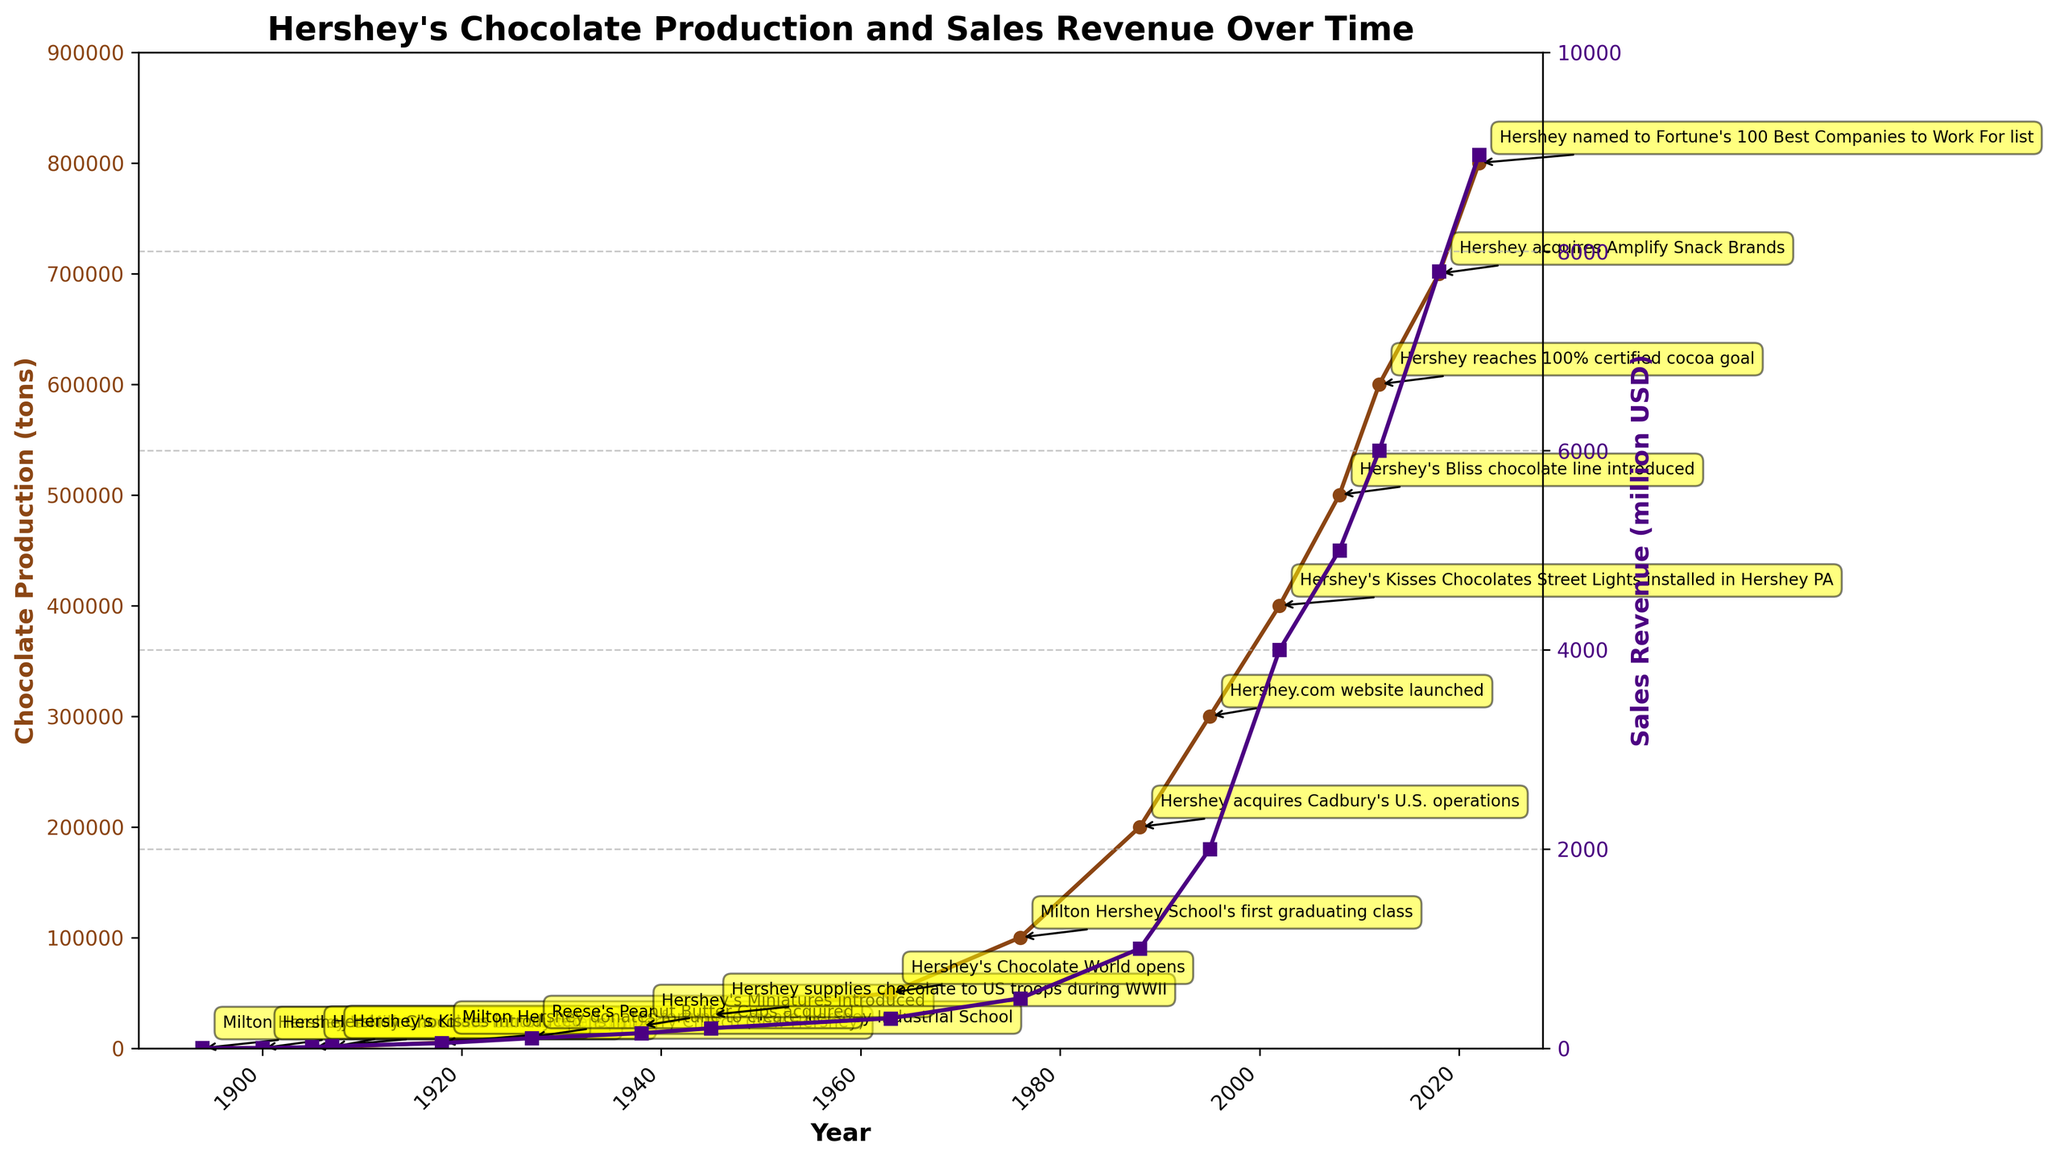What was the chocolate production in tons when Hershey acquired Reese's Peanut Butter Cups? Locate the key milestone "Reese's Peanut Butter Cups acquired" in 1927, and check the corresponding chocolate production value.
Answer: 10,000 tons When did Hershey first reach 300,000 tons of chocolate production? Look for the first occurrence of the chocolate production value reaching 300,000 tons on the x-axis. It reaches this level in 1995.
Answer: 1995 How much higher was the chocolate production in 2018 compared to 2008? Subtract the chocolate production value in 2008 from that in 2018: 700,000 - 500,000.
Answer: 200,000 tons Which year had the highest sales revenue and what was the amount? Identify the highest point on the sales revenue y-axis and note the corresponding year and value. In 2022, sales revenue was the highest at 8,971 million USD.
Answer: 2022; 8,971 million USD Identify the first year Hershey's chocolate production exceeded 100,000 tons. Look along the timeline for the first instance when chocolate production surpasses 100,000 tons. This happens in 1976.
Answer: 1976 Compare the chocolate production in the year Hershey’s Milk Chocolate Bar was introduced to the production in the year Hershey.com was launched. Check the chocolate production values for 1900 and 1995, then note the comparison: 50 tons (1900) vs. 300,000 tons (1995).
Answer: 50 tons vs. 300,000 tons How much did the sales revenue increase from 1988 to 2002? Subtract the sales revenue in 1988 from that in 2002: 4,000 million USD - 1,000 million USD.
Answer: 3,000 million USD Identify the year when Hershey started supplying chocolate to US troops and describe the trend in chocolate production after that year. Note that Hershey supplied chocolate to US troops in 1945. After 1945, the chocolate production continued to increase significantly.
Answer: 1945; increasing trend What is the average annual sales revenue growth from 2012 to 2018? Calculate the growth in sales revenue from 2012 (6,000 million USD) to 2018 (7,800 million USD): (7,800 - 6,000) / 6 years.
Answer: 300 million USD per year In which year was Hershey named to Fortune's 100 Best Companies to Work For list, and what was the chocolate production and sales revenue that year? Identify the key milestone "Hershey named to Fortune's 100 Best Companies to Work For list" in 2022, and note the corresponding chocolate production and sales revenue: 800,000 tons and 8,971 million USD.
Answer: 2022; 800,000 tons; 8,971 million USD 